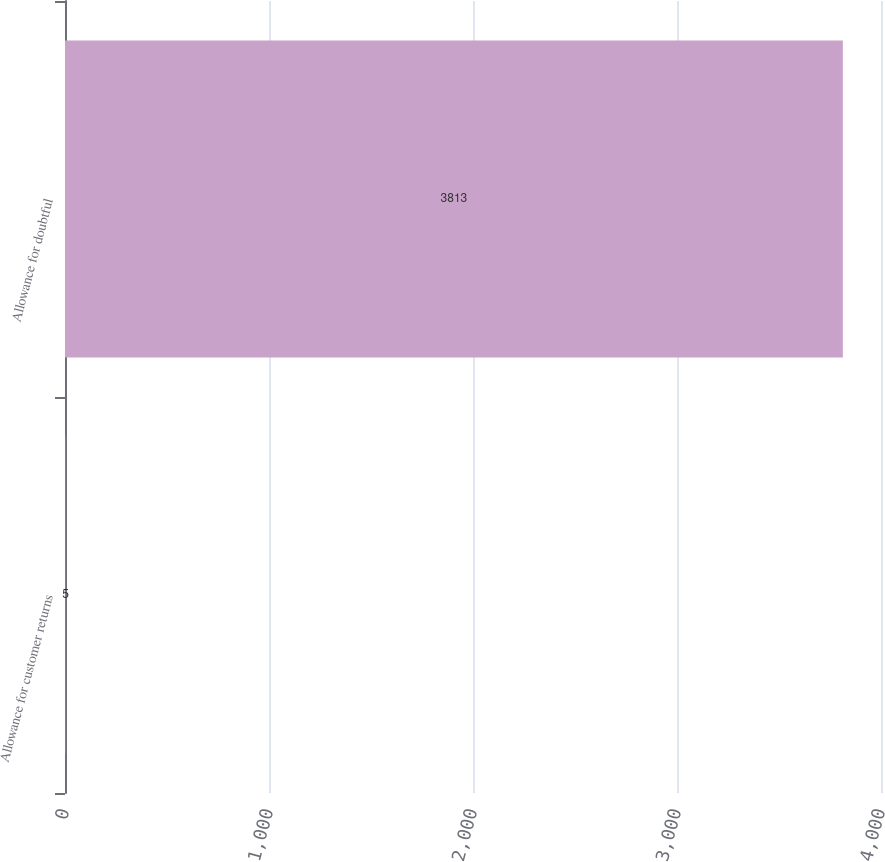<chart> <loc_0><loc_0><loc_500><loc_500><bar_chart><fcel>Allowance for customer returns<fcel>Allowance for doubtful<nl><fcel>5<fcel>3813<nl></chart> 